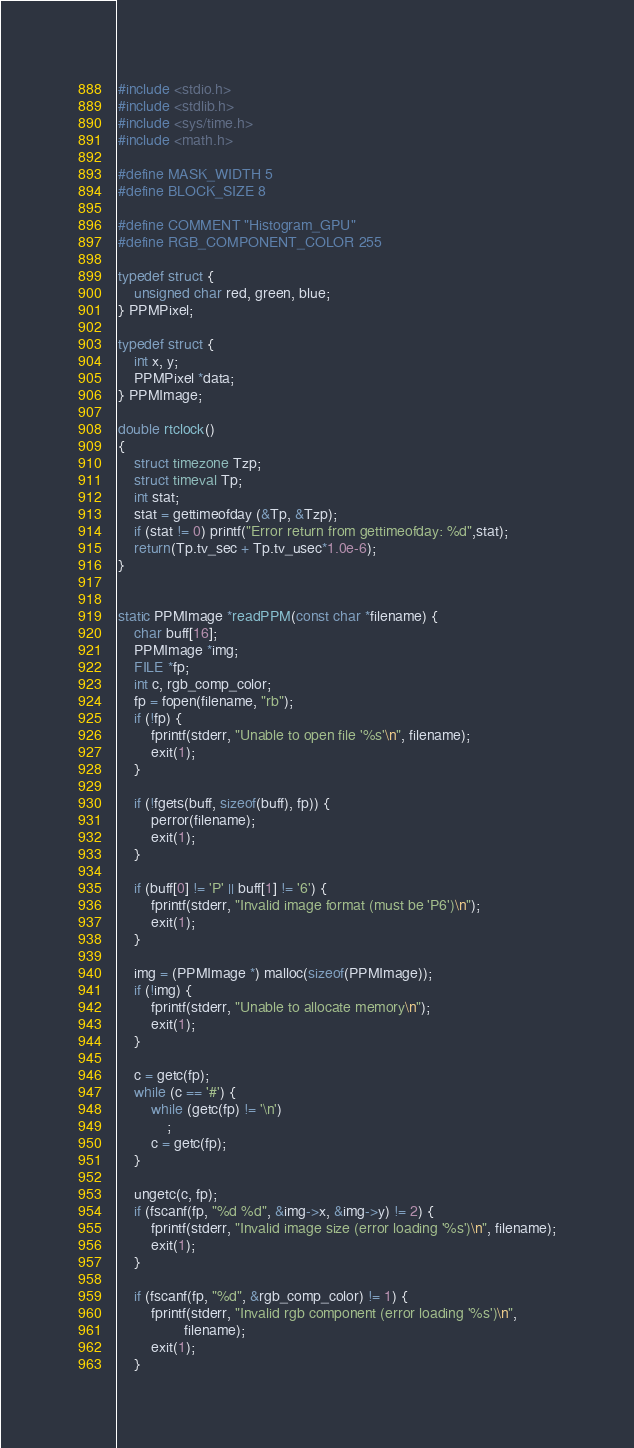Convert code to text. <code><loc_0><loc_0><loc_500><loc_500><_Cuda_>#include <stdio.h>
#include <stdlib.h>
#include <sys/time.h>
#include <math.h>

#define MASK_WIDTH 5
#define BLOCK_SIZE 8

#define COMMENT "Histogram_GPU"
#define RGB_COMPONENT_COLOR 255

typedef struct {
    unsigned char red, green, blue;
} PPMPixel;

typedef struct {
    int x, y;
    PPMPixel *data;
} PPMImage;

double rtclock()
{
    struct timezone Tzp;
    struct timeval Tp;
    int stat;
    stat = gettimeofday (&Tp, &Tzp);
    if (stat != 0) printf("Error return from gettimeofday: %d",stat);
    return(Tp.tv_sec + Tp.tv_usec*1.0e-6);
}


static PPMImage *readPPM(const char *filename) {
    char buff[16];
    PPMImage *img;
    FILE *fp;
    int c, rgb_comp_color;
    fp = fopen(filename, "rb");
    if (!fp) {
        fprintf(stderr, "Unable to open file '%s'\n", filename);
        exit(1);
    }

    if (!fgets(buff, sizeof(buff), fp)) {
        perror(filename);
        exit(1);
    }

    if (buff[0] != 'P' || buff[1] != '6') {
        fprintf(stderr, "Invalid image format (must be 'P6')\n");
        exit(1);
    }

    img = (PPMImage *) malloc(sizeof(PPMImage));
    if (!img) {
        fprintf(stderr, "Unable to allocate memory\n");
        exit(1);
    }

    c = getc(fp);
    while (c == '#') {
        while (getc(fp) != '\n')
            ;
        c = getc(fp);
    }

    ungetc(c, fp);
    if (fscanf(fp, "%d %d", &img->x, &img->y) != 2) {
        fprintf(stderr, "Invalid image size (error loading '%s')\n", filename);
        exit(1);
    }

    if (fscanf(fp, "%d", &rgb_comp_color) != 1) {
        fprintf(stderr, "Invalid rgb component (error loading '%s')\n",
                filename);
        exit(1);
    }
</code> 